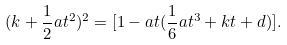Convert formula to latex. <formula><loc_0><loc_0><loc_500><loc_500>( k + \frac { 1 } { 2 } a t ^ { 2 } ) ^ { 2 } = [ 1 - a t ( \frac { 1 } { 6 } a t ^ { 3 } + k t + d ) ] .</formula> 